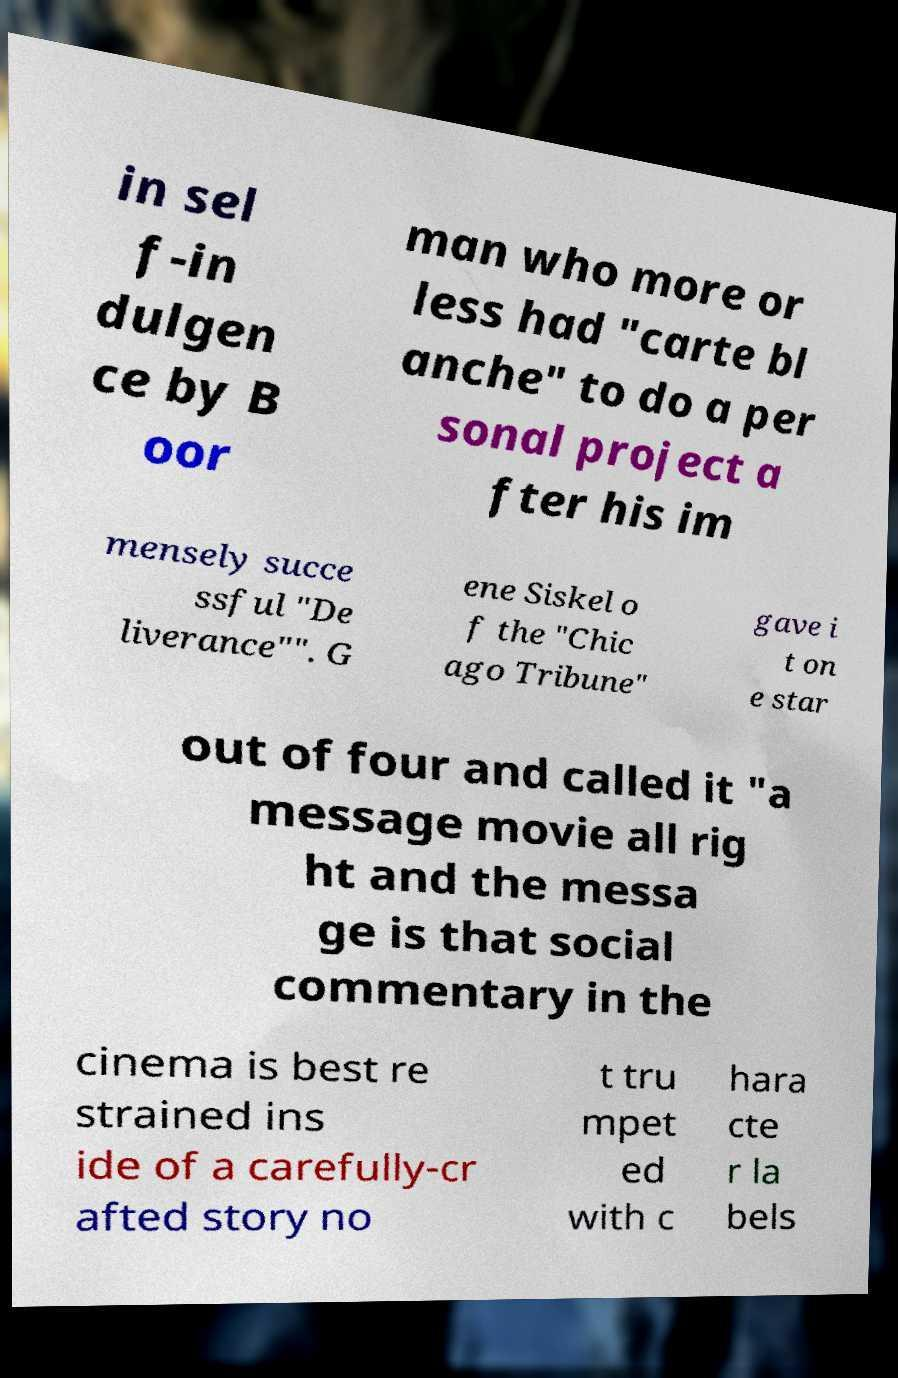Can you read and provide the text displayed in the image?This photo seems to have some interesting text. Can you extract and type it out for me? in sel f-in dulgen ce by B oor man who more or less had "carte bl anche" to do a per sonal project a fter his im mensely succe ssful "De liverance"". G ene Siskel o f the "Chic ago Tribune" gave i t on e star out of four and called it "a message movie all rig ht and the messa ge is that social commentary in the cinema is best re strained ins ide of a carefully-cr afted story no t tru mpet ed with c hara cte r la bels 